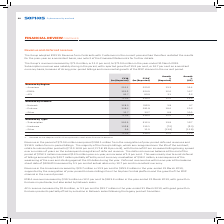According to Sophos Group's financial document, What was the reported percentage increase in EMEA revenue in 2019 from 2018? According to the financial document, 12.0 per cent. The relevant text states: "EMEA revenue increased by $39.1 million or 12.0 per cent to $363.6 million in the year-ended 31 March 2019, with growth in Enduser in particular, but also a..." Also, What was the reported percentage increase in APJ revenue in 2019 from 2018? According to the financial document, 3.1 per cent. The relevant text states: "APJ revenue increased by $2.8 million, or 3.1 per cent to $93.7 million in the year-ended 31 March 2019, with good growth in Enduser products partially of..." Also, What are the different regions under Revenue by Region in the table? The document contains multiple relevant values: Americas, EMEA, APJ. From the document: "– EMEA 363.6 324.5 12.0 12.7 – APJ 93.7 90.9 3.1 6.2 – Americas 253.3 223.6 13.3 13.4..." Additionally, In which year was the revenue in the Americas larger? According to the financial document, 2019. The relevant text states: "ent, to $710.6 million in the year-ended 31 March 2019. Subscription revenue was notably strong in the period, with reported growth of 15.9 per cent, or 1..." Also, can you calculate: What was the change in Network from 2019 to 2018 under Revenue by Product? Based on the calculation: 328.5-316.5, the result is 12 (in millions). This is based on the information: "– Network 328.5 316.5 3.8 4.7 – Network 328.5 316.5 3.8 4.7..." The key data points involved are: 316.5, 328.5. Also, can you calculate: What was the average revenue earned across 2018 and 2019? To answer this question, I need to perform calculations using the financial data. The calculation is: (710.6+639.0)/2, which equals 674.8 (in millions). This is based on the information: "710.6 639.0 11.2 12.0 710.6 639.0 11.2 12.0..." The key data points involved are: 639.0, 710.6. 